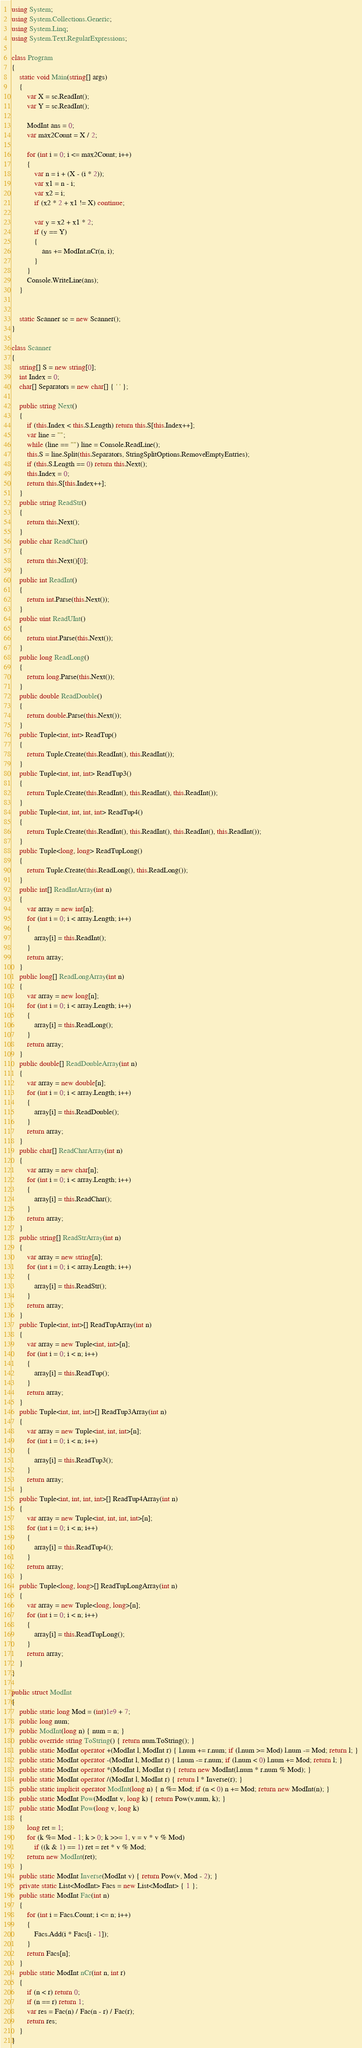<code> <loc_0><loc_0><loc_500><loc_500><_C#_>using System;
using System.Collections.Generic;
using System.Linq;
using System.Text.RegularExpressions;

class Program
{
    static void Main(string[] args)
    {
        var X = sc.ReadInt();
        var Y = sc.ReadInt();

        ModInt ans = 0;
        var max2Count = X / 2;

        for (int i = 0; i <= max2Count; i++)
        {
            var n = i + (X - (i * 2));
            var x1 = n - i;
            var x2 = i;
            if (x2 * 2 + x1 != X) continue;

            var y = x2 + x1 * 2;
            if (y == Y)
            {
                ans += ModInt.nCr(n, i);
            }
        }
        Console.WriteLine(ans);
    }


    static Scanner sc = new Scanner();
}

class Scanner
{
    string[] S = new string[0];
    int Index = 0;
    char[] Separators = new char[] { ' ' };

    public string Next()
    {
        if (this.Index < this.S.Length) return this.S[this.Index++];
        var line = "";
        while (line == "") line = Console.ReadLine();
        this.S = line.Split(this.Separators, StringSplitOptions.RemoveEmptyEntries);
        if (this.S.Length == 0) return this.Next();
        this.Index = 0;
        return this.S[this.Index++];
    }
    public string ReadStr()
    {
        return this.Next();
    }
    public char ReadChar()
    {
        return this.Next()[0];
    }
    public int ReadInt()
    {
        return int.Parse(this.Next());
    }
    public uint ReadUInt()
    {
        return uint.Parse(this.Next());
    }
    public long ReadLong()
    {
        return long.Parse(this.Next());
    }
    public double ReadDouble()
    {
        return double.Parse(this.Next());
    }
    public Tuple<int, int> ReadTup()
    {
        return Tuple.Create(this.ReadInt(), this.ReadInt());
    }
    public Tuple<int, int, int> ReadTup3()
    {
        return Tuple.Create(this.ReadInt(), this.ReadInt(), this.ReadInt());
    }
    public Tuple<int, int, int, int> ReadTup4()
    {
        return Tuple.Create(this.ReadInt(), this.ReadInt(), this.ReadInt(), this.ReadInt());
    }
    public Tuple<long, long> ReadTupLong()
    {
        return Tuple.Create(this.ReadLong(), this.ReadLong());
    }
    public int[] ReadIntArray(int n)
    {
        var array = new int[n];
        for (int i = 0; i < array.Length; i++)
        {
            array[i] = this.ReadInt();
        }
        return array;
    }
    public long[] ReadLongArray(int n)
    {
        var array = new long[n];
        for (int i = 0; i < array.Length; i++)
        {
            array[i] = this.ReadLong();
        }
        return array;
    }
    public double[] ReadDoubleArray(int n)
    {
        var array = new double[n];
        for (int i = 0; i < array.Length; i++)
        {
            array[i] = this.ReadDouble();
        }
        return array;
    }
    public char[] ReadCharArray(int n)
    {
        var array = new char[n];
        for (int i = 0; i < array.Length; i++)
        {
            array[i] = this.ReadChar();
        }
        return array;
    }
    public string[] ReadStrArray(int n)
    {
        var array = new string[n];
        for (int i = 0; i < array.Length; i++)
        {
            array[i] = this.ReadStr();
        }
        return array;
    }
    public Tuple<int, int>[] ReadTupArray(int n)
    {
        var array = new Tuple<int, int>[n];
        for (int i = 0; i < n; i++)
        {
            array[i] = this.ReadTup();
        }
        return array;
    }
    public Tuple<int, int, int>[] ReadTup3Array(int n)
    {
        var array = new Tuple<int, int, int>[n];
        for (int i = 0; i < n; i++)
        {
            array[i] = this.ReadTup3();
        }
        return array;
    }
    public Tuple<int, int, int, int>[] ReadTup4Array(int n)
    {
        var array = new Tuple<int, int, int, int>[n];
        for (int i = 0; i < n; i++)
        {
            array[i] = this.ReadTup4();
        }
        return array;
    }
    public Tuple<long, long>[] ReadTupLongArray(int n)
    {
        var array = new Tuple<long, long>[n];
        for (int i = 0; i < n; i++)
        {
            array[i] = this.ReadTupLong();
        }
        return array;
    }
}

public struct ModInt
{
    public static long Mod = (int)1e9 + 7;
    public long num;
    public ModInt(long n) { num = n; }
    public override string ToString() { return num.ToString(); }
    public static ModInt operator +(ModInt l, ModInt r) { l.num += r.num; if (l.num >= Mod) l.num -= Mod; return l; }
    public static ModInt operator -(ModInt l, ModInt r) { l.num -= r.num; if (l.num < 0) l.num += Mod; return l; }
    public static ModInt operator *(ModInt l, ModInt r) { return new ModInt(l.num * r.num % Mod); }
    public static ModInt operator /(ModInt l, ModInt r) { return l * Inverse(r); }
    public static implicit operator ModInt(long n) { n %= Mod; if (n < 0) n += Mod; return new ModInt(n); }
    public static ModInt Pow(ModInt v, long k) { return Pow(v.num, k); }
    public static ModInt Pow(long v, long k)
    {
        long ret = 1;
        for (k %= Mod - 1; k > 0; k >>= 1, v = v * v % Mod)
            if ((k & 1) == 1) ret = ret * v % Mod;
        return new ModInt(ret);
    }
    public static ModInt Inverse(ModInt v) { return Pow(v, Mod - 2); }
    private static List<ModInt> Facs = new List<ModInt> { 1 };
    public static ModInt Fac(int n)
    {
        for (int i = Facs.Count; i <= n; i++)
        {
            Facs.Add(i * Facs[i - 1]);
        }
        return Facs[n];
    }
    public static ModInt nCr(int n, int r)
    {
        if (n < r) return 0;
        if (n == r) return 1;
        var res = Fac(n) / Fac(n - r) / Fac(r);
        return res;
    }
}
</code> 